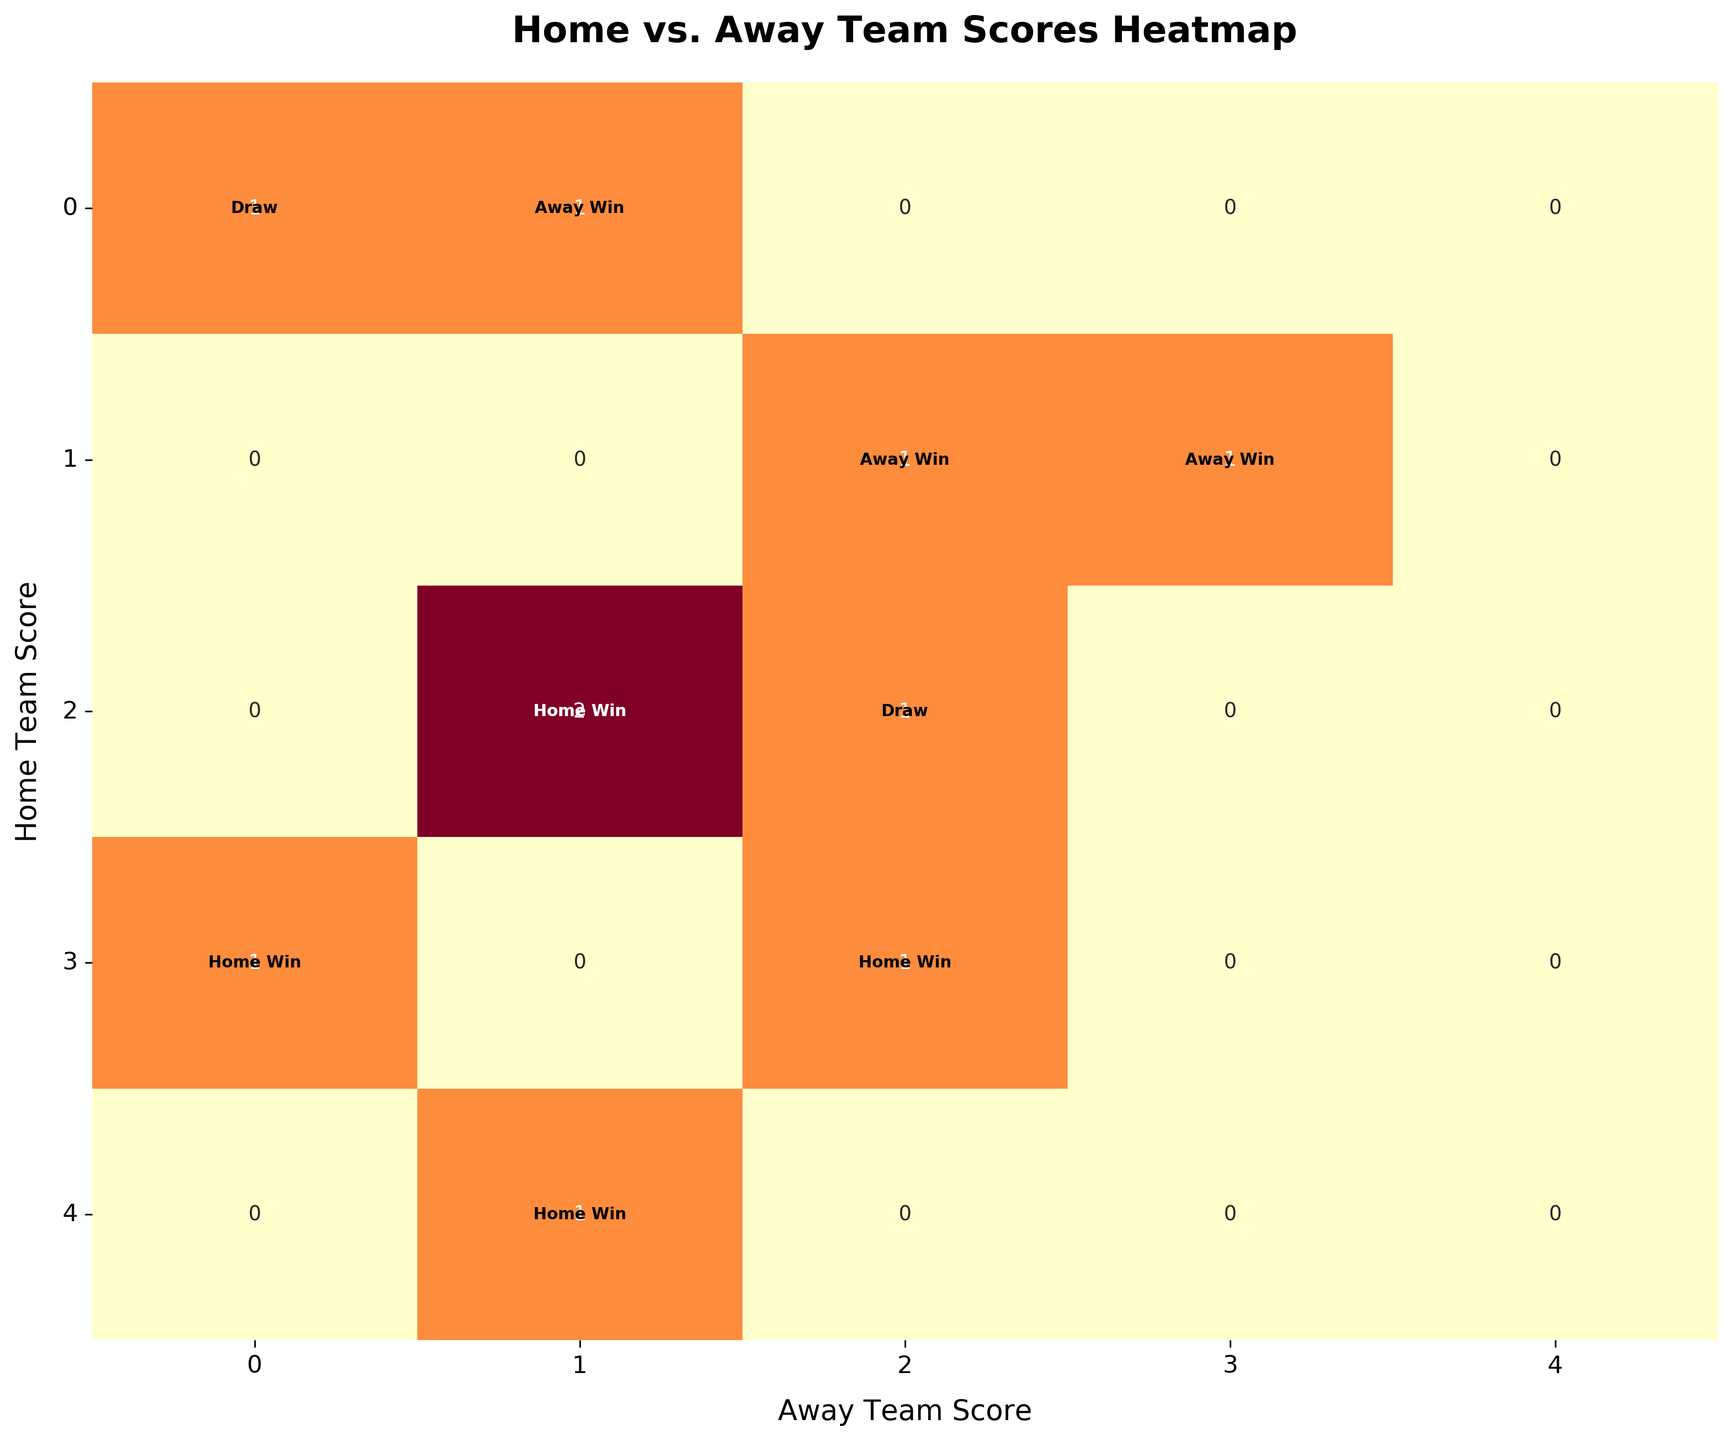What does the title of the heatmap indicate? By reading the title, we can understand that the heatmap displays the correlation between home and away team scores in football matches and their outcomes.
Answer: Home vs. Away Team Scores Heatmap What are the labels of the x-axis and y-axis? The x-axis label represents the "Away Team Score," and the y-axis label represents the "Home Team Score." This information can be understood by reading the axes labels.
Answer: Away Team Score, Home Team Score What is the highest score combination depicted in the heatmap? By examining the heatmap, we can find the highest values in both axes. The highest combination shown is "Home Score" of 4 and "Away Score" of 3.
Answer: 4, 3 How many matches ended in a "Home Win" when the home team scored 3 goals? By looking for all cases where the home team scored 3 goals and checking the textual annotations for "Home Win," we find two instances highlighted in the heatmap when the home team had 3 goals.
Answer: 2 What is the match outcome when the home team scored 2 and the away team scored 2? By finding the cell where 2 (home) intersects with 2 (away) and checking the text annotation inside the cell, we determine the match outcome is a "Draw."
Answer: Draw Which score combination has the most frequent occurrences in the heatmap? By identifying the cell with the highest numerical value (count), we find the most commonly occurring score combination. In this case, it's the cell (2, 1).
Answer: (2, 1) Is there any match outcome annotated within the cells where the home and away scores are both zero? By examining the cell where both scores are zero, we observe the textual annotation inside the cell, which indicates a "Draw."
Answer: Draw Are there more matches where the home team won or where the away team won? By summing the number of "Home Win" annotations and comparing it to the total number of "Away Win" annotations, we see more "Home Win" outcomes.
Answer: Home Win What is the total number of draws shown in the heatmap? By counting all the cells marked with "Draw," we see that there are two matches ended in a draw.
Answer: 2 Which team victory types appear in the heatmap when the home team has no goals scored? By examining all cells in the row where the home team has zero goals (Home Score = 0), we see the outcomes annotated inside these cells are for "Away Win."
Answer: Away Win 